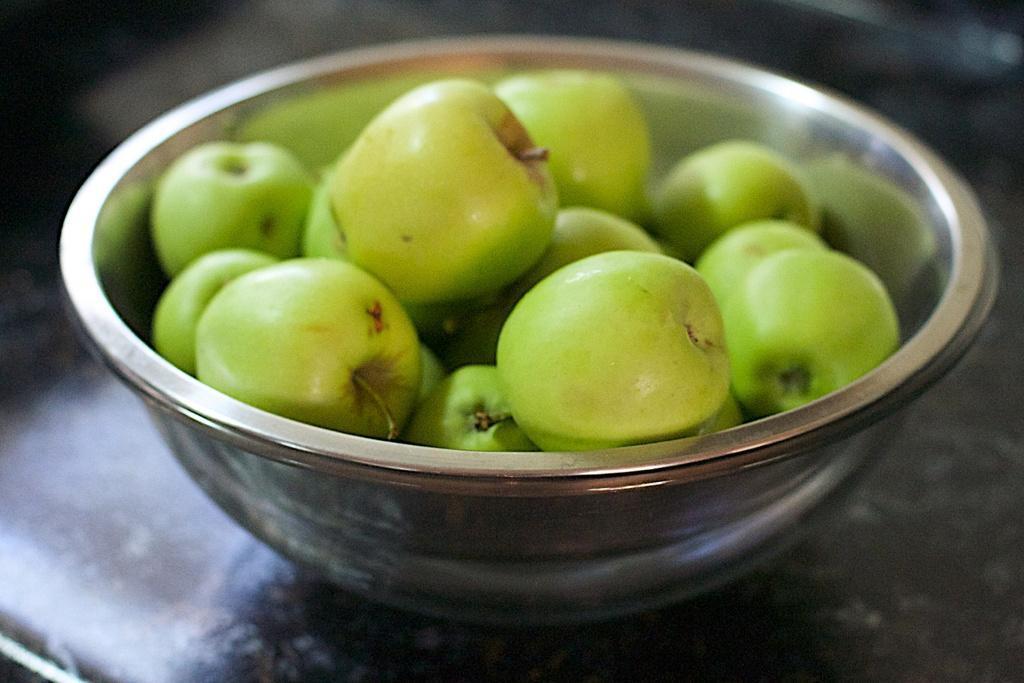How would you summarize this image in a sentence or two? In this picture we can see a steel bowl with fruits in it and this bowl is placed on a platform. 